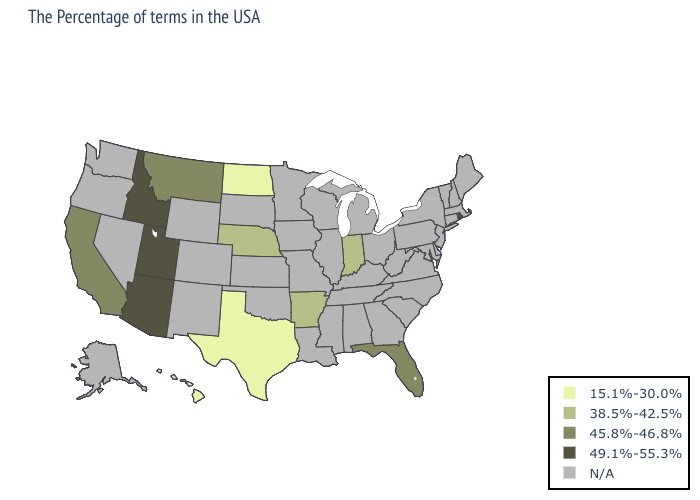Name the states that have a value in the range N/A?
Be succinct. Maine, Massachusetts, New Hampshire, Vermont, Connecticut, New York, New Jersey, Delaware, Maryland, Pennsylvania, Virginia, North Carolina, South Carolina, West Virginia, Ohio, Georgia, Michigan, Kentucky, Alabama, Tennessee, Wisconsin, Illinois, Mississippi, Louisiana, Missouri, Minnesota, Iowa, Kansas, Oklahoma, South Dakota, Wyoming, Colorado, New Mexico, Nevada, Washington, Oregon, Alaska. Name the states that have a value in the range 15.1%-30.0%?
Concise answer only. Texas, North Dakota, Hawaii. Name the states that have a value in the range 45.8%-46.8%?
Answer briefly. Florida, Montana, California. Which states have the lowest value in the South?
Quick response, please. Texas. What is the value of Delaware?
Short answer required. N/A. How many symbols are there in the legend?
Keep it brief. 5. Which states have the lowest value in the Northeast?
Write a very short answer. Rhode Island. What is the lowest value in the USA?
Be succinct. 15.1%-30.0%. What is the highest value in the South ?
Be succinct. 45.8%-46.8%. Which states have the lowest value in the USA?
Be succinct. Texas, North Dakota, Hawaii. Among the states that border Louisiana , does Texas have the lowest value?
Keep it brief. Yes. 